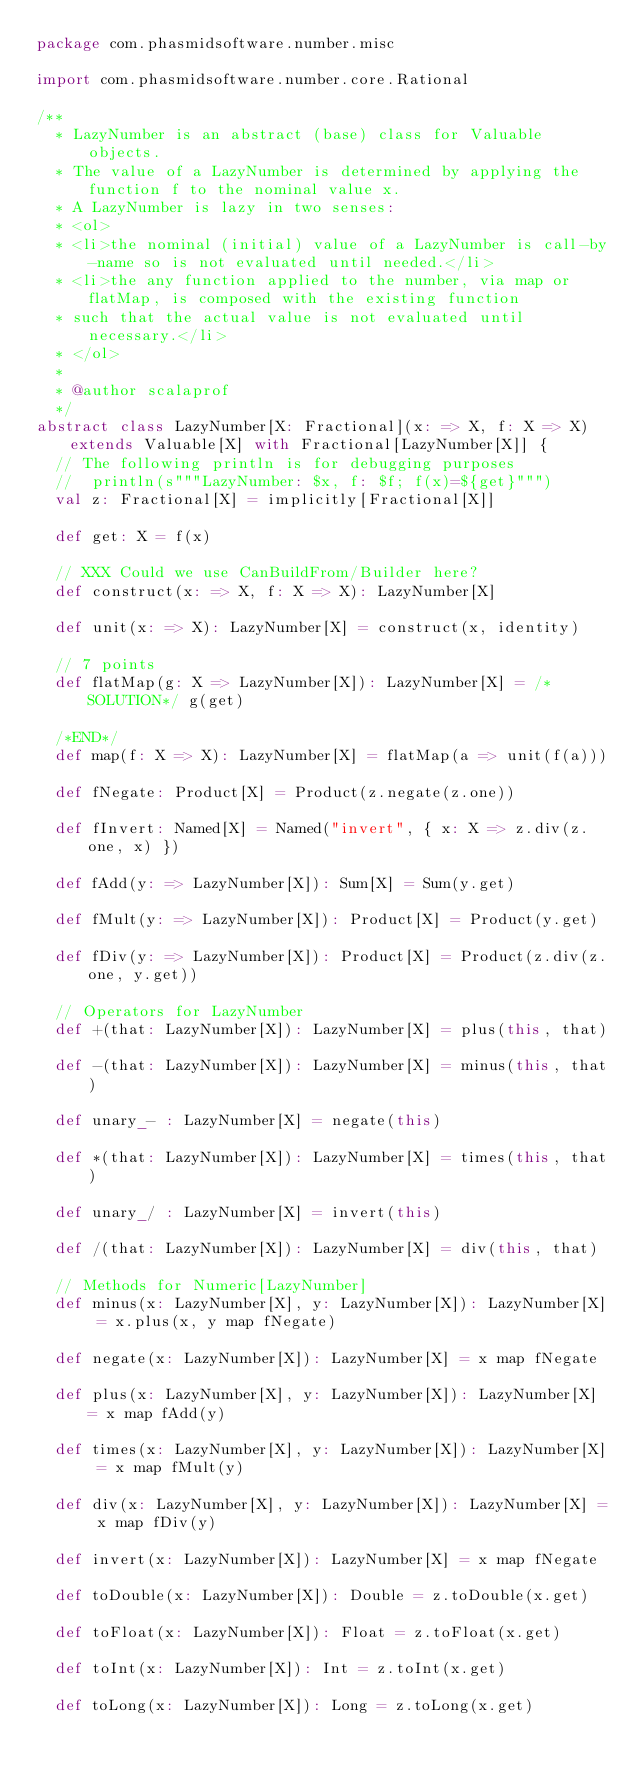Convert code to text. <code><loc_0><loc_0><loc_500><loc_500><_Scala_>package com.phasmidsoftware.number.misc

import com.phasmidsoftware.number.core.Rational

/**
  * LazyNumber is an abstract (base) class for Valuable objects.
  * The value of a LazyNumber is determined by applying the function f to the nominal value x.
  * A LazyNumber is lazy in two senses:
  * <ol>
  * <li>the nominal (initial) value of a LazyNumber is call-by-name so is not evaluated until needed.</li>
  * <li>the any function applied to the number, via map or flatMap, is composed with the existing function
  * such that the actual value is not evaluated until necessary.</li>
  * </ol>
  *
  * @author scalaprof
  */
abstract class LazyNumber[X: Fractional](x: => X, f: X => X) extends Valuable[X] with Fractional[LazyNumber[X]] {
  // The following println is for debugging purposes
  //  println(s"""LazyNumber: $x, f: $f; f(x)=${get}""")
  val z: Fractional[X] = implicitly[Fractional[X]]

  def get: X = f(x)

  // XXX Could we use CanBuildFrom/Builder here?
  def construct(x: => X, f: X => X): LazyNumber[X]

  def unit(x: => X): LazyNumber[X] = construct(x, identity)

  // 7 points
  def flatMap(g: X => LazyNumber[X]): LazyNumber[X] = /*SOLUTION*/ g(get)

  /*END*/
  def map(f: X => X): LazyNumber[X] = flatMap(a => unit(f(a)))

  def fNegate: Product[X] = Product(z.negate(z.one))

  def fInvert: Named[X] = Named("invert", { x: X => z.div(z.one, x) })

  def fAdd(y: => LazyNumber[X]): Sum[X] = Sum(y.get)

  def fMult(y: => LazyNumber[X]): Product[X] = Product(y.get)

  def fDiv(y: => LazyNumber[X]): Product[X] = Product(z.div(z.one, y.get))

  // Operators for LazyNumber
  def +(that: LazyNumber[X]): LazyNumber[X] = plus(this, that)

  def -(that: LazyNumber[X]): LazyNumber[X] = minus(this, that)

  def unary_- : LazyNumber[X] = negate(this)

  def *(that: LazyNumber[X]): LazyNumber[X] = times(this, that)

  def unary_/ : LazyNumber[X] = invert(this)

  def /(that: LazyNumber[X]): LazyNumber[X] = div(this, that)

  // Methods for Numeric[LazyNumber]
  def minus(x: LazyNumber[X], y: LazyNumber[X]): LazyNumber[X] = x.plus(x, y map fNegate)

  def negate(x: LazyNumber[X]): LazyNumber[X] = x map fNegate

  def plus(x: LazyNumber[X], y: LazyNumber[X]): LazyNumber[X] = x map fAdd(y)

  def times(x: LazyNumber[X], y: LazyNumber[X]): LazyNumber[X] = x map fMult(y)

  def div(x: LazyNumber[X], y: LazyNumber[X]): LazyNumber[X] = x map fDiv(y)

  def invert(x: LazyNumber[X]): LazyNumber[X] = x map fNegate

  def toDouble(x: LazyNumber[X]): Double = z.toDouble(x.get)

  def toFloat(x: LazyNumber[X]): Float = z.toFloat(x.get)

  def toInt(x: LazyNumber[X]): Int = z.toInt(x.get)

  def toLong(x: LazyNumber[X]): Long = z.toLong(x.get)
</code> 